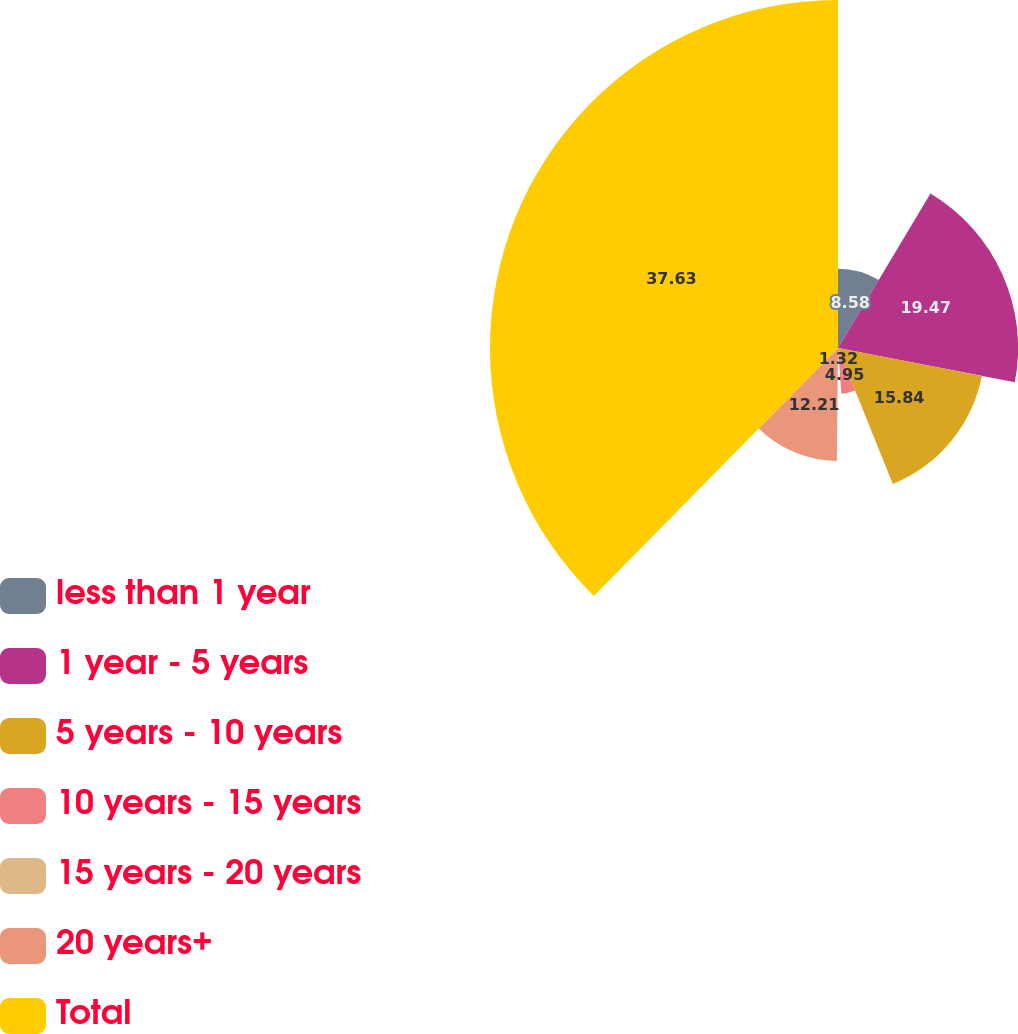<chart> <loc_0><loc_0><loc_500><loc_500><pie_chart><fcel>less than 1 year<fcel>1 year - 5 years<fcel>5 years - 10 years<fcel>10 years - 15 years<fcel>15 years - 20 years<fcel>20 years+<fcel>Total<nl><fcel>8.58%<fcel>19.47%<fcel>15.84%<fcel>4.95%<fcel>1.32%<fcel>12.21%<fcel>37.62%<nl></chart> 